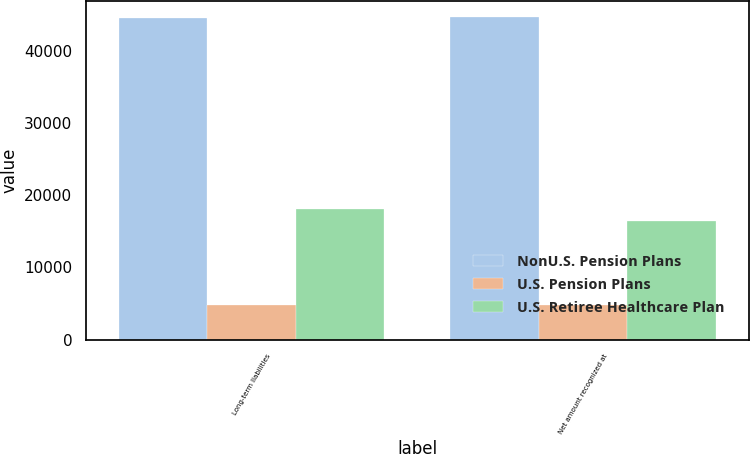Convert chart. <chart><loc_0><loc_0><loc_500><loc_500><stacked_bar_chart><ecel><fcel>Long-term liabilities<fcel>Net amount recognized at<nl><fcel>NonU.S. Pension Plans<fcel>44497<fcel>44646<nl><fcel>U.S. Pension Plans<fcel>4827<fcel>4827<nl><fcel>U.S. Retiree Healthcare Plan<fcel>18106<fcel>16397<nl></chart> 